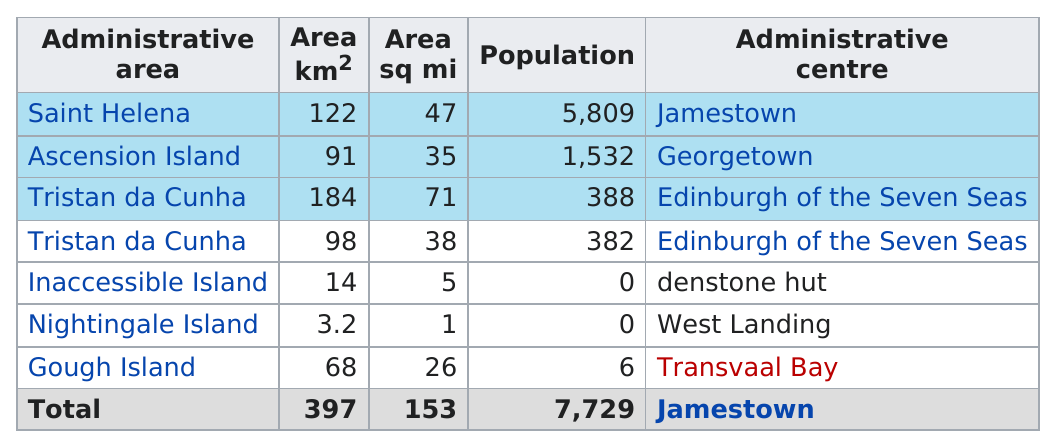Indicate a few pertinent items in this graphic. Inaccessible Island comes before Nightingale Island in the administrative area. Out of the administrative areas, how many have a population below 500? The administrative area with the lowest population that is not zero is Gough Island. The difference between the area with the highest population and the lowest population is 5809. There are two administrative areas that have a population of at least 500. 